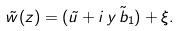Convert formula to latex. <formula><loc_0><loc_0><loc_500><loc_500>\tilde { w } ( z ) = ( \tilde { u } + i \, y \, \tilde { b } _ { 1 } ) + \xi .</formula> 